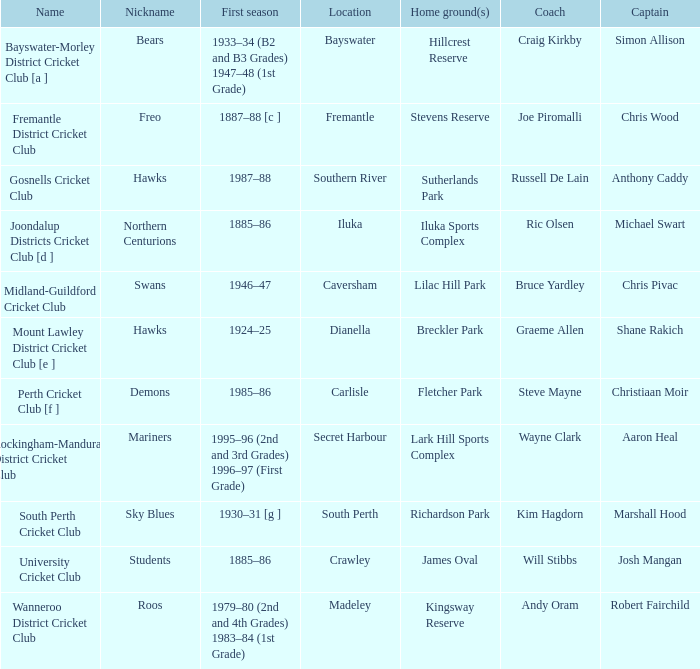What is the dates where Hillcrest Reserve is the home grounds? 1933–34 (B2 and B3 Grades) 1947–48 (1st Grade). 